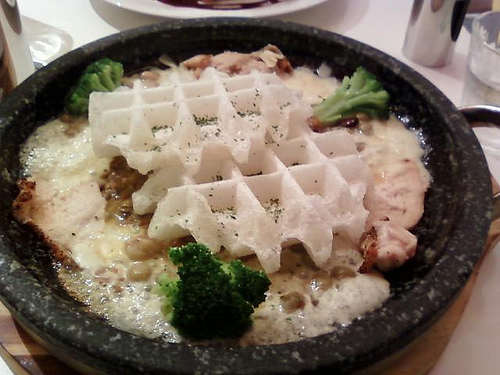<image>
Is there a waffle in the gravy? Yes. The waffle is contained within or inside the gravy, showing a containment relationship. Is the black pepper on the waffle? Yes. Looking at the image, I can see the black pepper is positioned on top of the waffle, with the waffle providing support. 